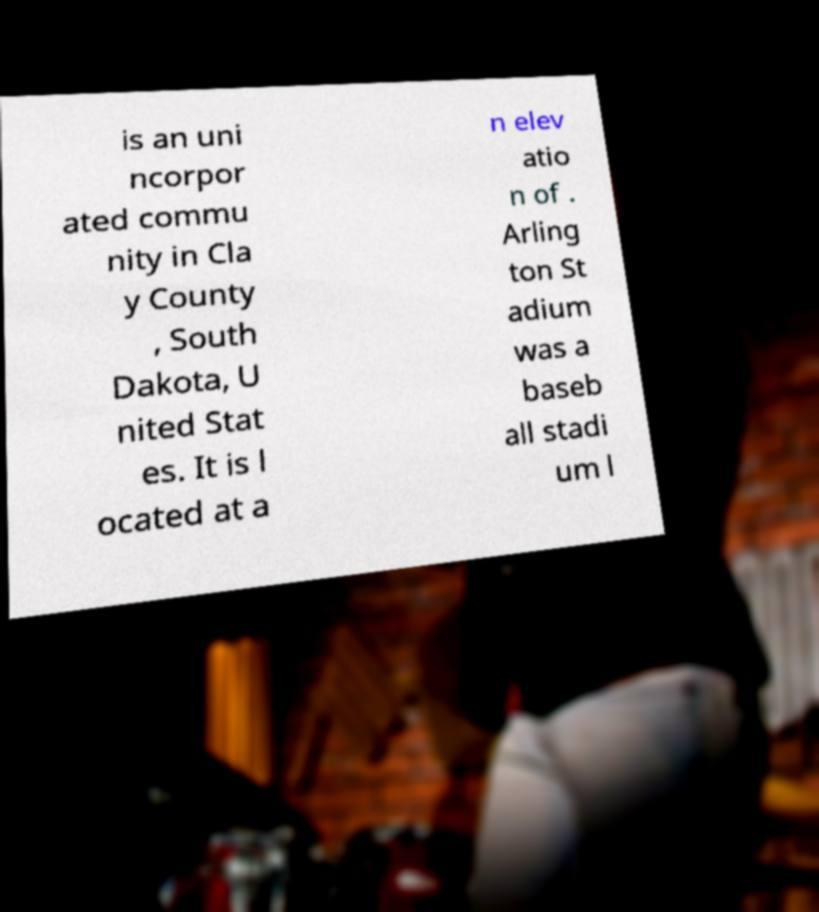I need the written content from this picture converted into text. Can you do that? is an uni ncorpor ated commu nity in Cla y County , South Dakota, U nited Stat es. It is l ocated at a n elev atio n of . Arling ton St adium was a baseb all stadi um l 